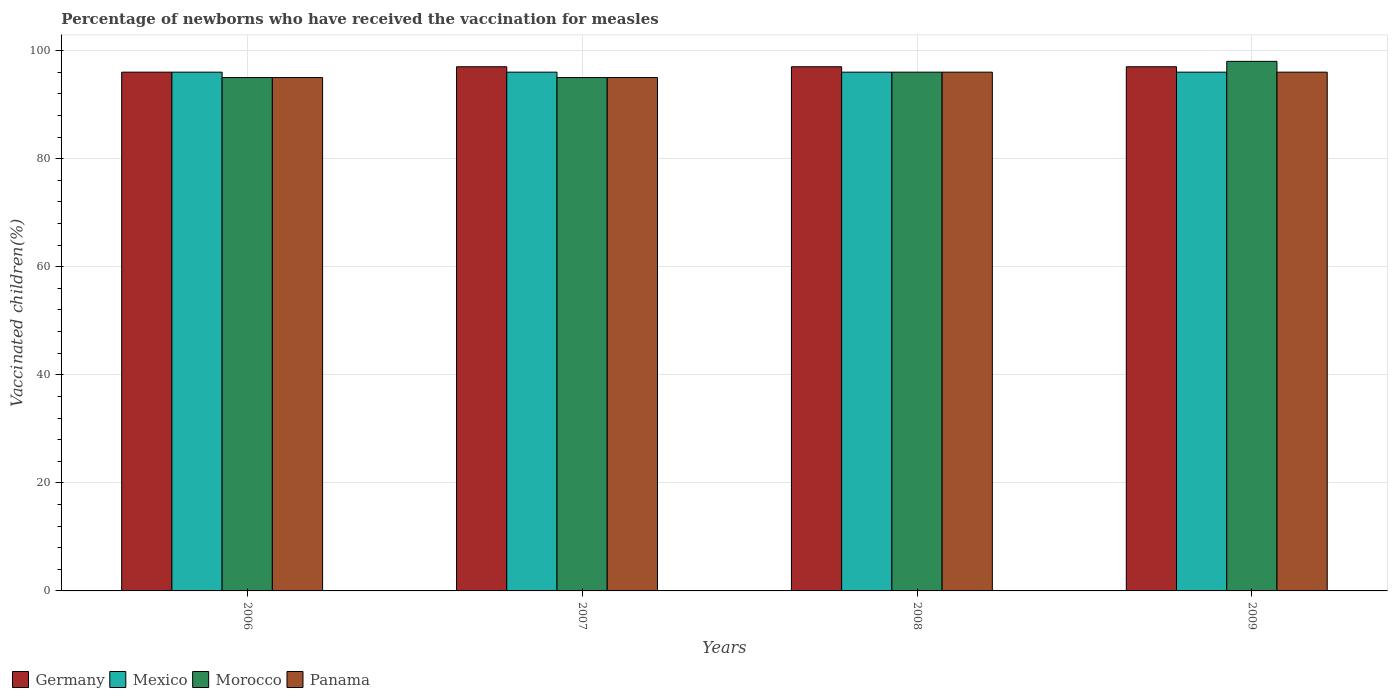How many different coloured bars are there?
Offer a very short reply. 4. Are the number of bars per tick equal to the number of legend labels?
Offer a terse response. Yes. How many bars are there on the 3rd tick from the left?
Ensure brevity in your answer.  4. What is the label of the 3rd group of bars from the left?
Offer a very short reply. 2008. In how many cases, is the number of bars for a given year not equal to the number of legend labels?
Your answer should be very brief. 0. What is the percentage of vaccinated children in Panama in 2007?
Offer a terse response. 95. Across all years, what is the maximum percentage of vaccinated children in Panama?
Your answer should be very brief. 96. Across all years, what is the minimum percentage of vaccinated children in Morocco?
Provide a short and direct response. 95. In which year was the percentage of vaccinated children in Mexico maximum?
Your answer should be compact. 2006. In which year was the percentage of vaccinated children in Mexico minimum?
Offer a very short reply. 2006. What is the total percentage of vaccinated children in Germany in the graph?
Provide a succinct answer. 387. What is the difference between the percentage of vaccinated children in Morocco in 2006 and that in 2007?
Make the answer very short. 0. What is the difference between the percentage of vaccinated children in Panama in 2007 and the percentage of vaccinated children in Morocco in 2006?
Your response must be concise. 0. What is the average percentage of vaccinated children in Mexico per year?
Make the answer very short. 96. In the year 2008, what is the difference between the percentage of vaccinated children in Germany and percentage of vaccinated children in Morocco?
Give a very brief answer. 1. What is the ratio of the percentage of vaccinated children in Panama in 2007 to that in 2009?
Ensure brevity in your answer.  0.99. What is the difference between the highest and the lowest percentage of vaccinated children in Germany?
Offer a very short reply. 1. In how many years, is the percentage of vaccinated children in Mexico greater than the average percentage of vaccinated children in Mexico taken over all years?
Your answer should be compact. 0. Is it the case that in every year, the sum of the percentage of vaccinated children in Morocco and percentage of vaccinated children in Panama is greater than the sum of percentage of vaccinated children in Germany and percentage of vaccinated children in Mexico?
Provide a short and direct response. No. What does the 2nd bar from the left in 2009 represents?
Your answer should be compact. Mexico. What does the 2nd bar from the right in 2007 represents?
Your response must be concise. Morocco. Is it the case that in every year, the sum of the percentage of vaccinated children in Germany and percentage of vaccinated children in Morocco is greater than the percentage of vaccinated children in Panama?
Keep it short and to the point. Yes. How many years are there in the graph?
Keep it short and to the point. 4. How many legend labels are there?
Offer a very short reply. 4. What is the title of the graph?
Give a very brief answer. Percentage of newborns who have received the vaccination for measles. What is the label or title of the Y-axis?
Provide a short and direct response. Vaccinated children(%). What is the Vaccinated children(%) of Germany in 2006?
Keep it short and to the point. 96. What is the Vaccinated children(%) in Mexico in 2006?
Offer a terse response. 96. What is the Vaccinated children(%) of Panama in 2006?
Your response must be concise. 95. What is the Vaccinated children(%) in Germany in 2007?
Your answer should be very brief. 97. What is the Vaccinated children(%) of Mexico in 2007?
Offer a very short reply. 96. What is the Vaccinated children(%) of Morocco in 2007?
Your answer should be compact. 95. What is the Vaccinated children(%) in Germany in 2008?
Provide a short and direct response. 97. What is the Vaccinated children(%) of Mexico in 2008?
Your answer should be compact. 96. What is the Vaccinated children(%) of Morocco in 2008?
Provide a succinct answer. 96. What is the Vaccinated children(%) of Panama in 2008?
Make the answer very short. 96. What is the Vaccinated children(%) of Germany in 2009?
Ensure brevity in your answer.  97. What is the Vaccinated children(%) in Mexico in 2009?
Give a very brief answer. 96. What is the Vaccinated children(%) in Panama in 2009?
Make the answer very short. 96. Across all years, what is the maximum Vaccinated children(%) of Germany?
Ensure brevity in your answer.  97. Across all years, what is the maximum Vaccinated children(%) in Mexico?
Make the answer very short. 96. Across all years, what is the maximum Vaccinated children(%) of Morocco?
Your answer should be compact. 98. Across all years, what is the maximum Vaccinated children(%) in Panama?
Provide a short and direct response. 96. Across all years, what is the minimum Vaccinated children(%) in Germany?
Ensure brevity in your answer.  96. Across all years, what is the minimum Vaccinated children(%) of Mexico?
Provide a short and direct response. 96. What is the total Vaccinated children(%) in Germany in the graph?
Provide a succinct answer. 387. What is the total Vaccinated children(%) in Mexico in the graph?
Keep it short and to the point. 384. What is the total Vaccinated children(%) of Morocco in the graph?
Provide a short and direct response. 384. What is the total Vaccinated children(%) in Panama in the graph?
Ensure brevity in your answer.  382. What is the difference between the Vaccinated children(%) of Germany in 2006 and that in 2007?
Keep it short and to the point. -1. What is the difference between the Vaccinated children(%) in Mexico in 2006 and that in 2007?
Your answer should be very brief. 0. What is the difference between the Vaccinated children(%) of Panama in 2006 and that in 2007?
Offer a very short reply. 0. What is the difference between the Vaccinated children(%) of Mexico in 2006 and that in 2008?
Offer a very short reply. 0. What is the difference between the Vaccinated children(%) in Morocco in 2006 and that in 2008?
Your answer should be very brief. -1. What is the difference between the Vaccinated children(%) in Germany in 2006 and that in 2009?
Ensure brevity in your answer.  -1. What is the difference between the Vaccinated children(%) of Morocco in 2006 and that in 2009?
Make the answer very short. -3. What is the difference between the Vaccinated children(%) of Panama in 2006 and that in 2009?
Give a very brief answer. -1. What is the difference between the Vaccinated children(%) in Mexico in 2007 and that in 2008?
Make the answer very short. 0. What is the difference between the Vaccinated children(%) in Morocco in 2007 and that in 2008?
Your response must be concise. -1. What is the difference between the Vaccinated children(%) of Germany in 2007 and that in 2009?
Your response must be concise. 0. What is the difference between the Vaccinated children(%) in Germany in 2008 and that in 2009?
Make the answer very short. 0. What is the difference between the Vaccinated children(%) in Mexico in 2008 and that in 2009?
Your answer should be compact. 0. What is the difference between the Vaccinated children(%) of Germany in 2006 and the Vaccinated children(%) of Mexico in 2007?
Your answer should be compact. 0. What is the difference between the Vaccinated children(%) in Mexico in 2006 and the Vaccinated children(%) in Panama in 2007?
Give a very brief answer. 1. What is the difference between the Vaccinated children(%) of Morocco in 2006 and the Vaccinated children(%) of Panama in 2007?
Offer a very short reply. 0. What is the difference between the Vaccinated children(%) in Mexico in 2006 and the Vaccinated children(%) in Morocco in 2008?
Keep it short and to the point. 0. What is the difference between the Vaccinated children(%) in Morocco in 2006 and the Vaccinated children(%) in Panama in 2008?
Ensure brevity in your answer.  -1. What is the difference between the Vaccinated children(%) of Mexico in 2006 and the Vaccinated children(%) of Morocco in 2009?
Provide a succinct answer. -2. What is the difference between the Vaccinated children(%) of Germany in 2007 and the Vaccinated children(%) of Mexico in 2008?
Your answer should be compact. 1. What is the difference between the Vaccinated children(%) of Germany in 2007 and the Vaccinated children(%) of Morocco in 2008?
Offer a very short reply. 1. What is the difference between the Vaccinated children(%) in Mexico in 2007 and the Vaccinated children(%) in Panama in 2008?
Provide a succinct answer. 0. What is the difference between the Vaccinated children(%) in Morocco in 2007 and the Vaccinated children(%) in Panama in 2008?
Offer a terse response. -1. What is the difference between the Vaccinated children(%) of Germany in 2007 and the Vaccinated children(%) of Morocco in 2009?
Provide a short and direct response. -1. What is the difference between the Vaccinated children(%) in Germany in 2007 and the Vaccinated children(%) in Panama in 2009?
Keep it short and to the point. 1. What is the difference between the Vaccinated children(%) in Morocco in 2007 and the Vaccinated children(%) in Panama in 2009?
Give a very brief answer. -1. What is the difference between the Vaccinated children(%) of Germany in 2008 and the Vaccinated children(%) of Morocco in 2009?
Give a very brief answer. -1. What is the difference between the Vaccinated children(%) of Germany in 2008 and the Vaccinated children(%) of Panama in 2009?
Give a very brief answer. 1. What is the difference between the Vaccinated children(%) in Mexico in 2008 and the Vaccinated children(%) in Morocco in 2009?
Offer a very short reply. -2. What is the difference between the Vaccinated children(%) of Mexico in 2008 and the Vaccinated children(%) of Panama in 2009?
Offer a terse response. 0. What is the difference between the Vaccinated children(%) in Morocco in 2008 and the Vaccinated children(%) in Panama in 2009?
Provide a short and direct response. 0. What is the average Vaccinated children(%) in Germany per year?
Your answer should be compact. 96.75. What is the average Vaccinated children(%) of Mexico per year?
Give a very brief answer. 96. What is the average Vaccinated children(%) of Morocco per year?
Your answer should be compact. 96. What is the average Vaccinated children(%) of Panama per year?
Your answer should be compact. 95.5. In the year 2006, what is the difference between the Vaccinated children(%) of Germany and Vaccinated children(%) of Morocco?
Ensure brevity in your answer.  1. In the year 2006, what is the difference between the Vaccinated children(%) of Mexico and Vaccinated children(%) of Morocco?
Make the answer very short. 1. In the year 2006, what is the difference between the Vaccinated children(%) in Mexico and Vaccinated children(%) in Panama?
Provide a succinct answer. 1. In the year 2007, what is the difference between the Vaccinated children(%) in Germany and Vaccinated children(%) in Mexico?
Give a very brief answer. 1. In the year 2007, what is the difference between the Vaccinated children(%) of Germany and Vaccinated children(%) of Panama?
Offer a very short reply. 2. In the year 2007, what is the difference between the Vaccinated children(%) of Mexico and Vaccinated children(%) of Morocco?
Make the answer very short. 1. In the year 2008, what is the difference between the Vaccinated children(%) of Germany and Vaccinated children(%) of Morocco?
Ensure brevity in your answer.  1. In the year 2008, what is the difference between the Vaccinated children(%) of Germany and Vaccinated children(%) of Panama?
Ensure brevity in your answer.  1. In the year 2008, what is the difference between the Vaccinated children(%) in Mexico and Vaccinated children(%) in Morocco?
Your answer should be compact. 0. In the year 2008, what is the difference between the Vaccinated children(%) of Mexico and Vaccinated children(%) of Panama?
Give a very brief answer. 0. In the year 2009, what is the difference between the Vaccinated children(%) of Germany and Vaccinated children(%) of Panama?
Give a very brief answer. 1. In the year 2009, what is the difference between the Vaccinated children(%) of Mexico and Vaccinated children(%) of Morocco?
Offer a very short reply. -2. In the year 2009, what is the difference between the Vaccinated children(%) of Mexico and Vaccinated children(%) of Panama?
Your answer should be compact. 0. What is the ratio of the Vaccinated children(%) in Germany in 2006 to that in 2007?
Keep it short and to the point. 0.99. What is the ratio of the Vaccinated children(%) of Mexico in 2006 to that in 2007?
Offer a terse response. 1. What is the ratio of the Vaccinated children(%) of Germany in 2006 to that in 2008?
Your response must be concise. 0.99. What is the ratio of the Vaccinated children(%) of Mexico in 2006 to that in 2008?
Your answer should be compact. 1. What is the ratio of the Vaccinated children(%) of Morocco in 2006 to that in 2008?
Provide a short and direct response. 0.99. What is the ratio of the Vaccinated children(%) in Panama in 2006 to that in 2008?
Provide a short and direct response. 0.99. What is the ratio of the Vaccinated children(%) in Germany in 2006 to that in 2009?
Keep it short and to the point. 0.99. What is the ratio of the Vaccinated children(%) in Morocco in 2006 to that in 2009?
Provide a short and direct response. 0.97. What is the ratio of the Vaccinated children(%) in Panama in 2006 to that in 2009?
Your response must be concise. 0.99. What is the ratio of the Vaccinated children(%) in Germany in 2007 to that in 2008?
Offer a terse response. 1. What is the ratio of the Vaccinated children(%) of Morocco in 2007 to that in 2008?
Offer a very short reply. 0.99. What is the ratio of the Vaccinated children(%) in Germany in 2007 to that in 2009?
Ensure brevity in your answer.  1. What is the ratio of the Vaccinated children(%) in Morocco in 2007 to that in 2009?
Keep it short and to the point. 0.97. What is the ratio of the Vaccinated children(%) of Panama in 2007 to that in 2009?
Offer a terse response. 0.99. What is the ratio of the Vaccinated children(%) of Mexico in 2008 to that in 2009?
Your answer should be compact. 1. What is the ratio of the Vaccinated children(%) of Morocco in 2008 to that in 2009?
Provide a succinct answer. 0.98. What is the difference between the highest and the second highest Vaccinated children(%) of Mexico?
Provide a short and direct response. 0. What is the difference between the highest and the second highest Vaccinated children(%) of Morocco?
Keep it short and to the point. 2. What is the difference between the highest and the second highest Vaccinated children(%) in Panama?
Provide a short and direct response. 0. What is the difference between the highest and the lowest Vaccinated children(%) in Germany?
Your response must be concise. 1. What is the difference between the highest and the lowest Vaccinated children(%) in Panama?
Offer a very short reply. 1. 